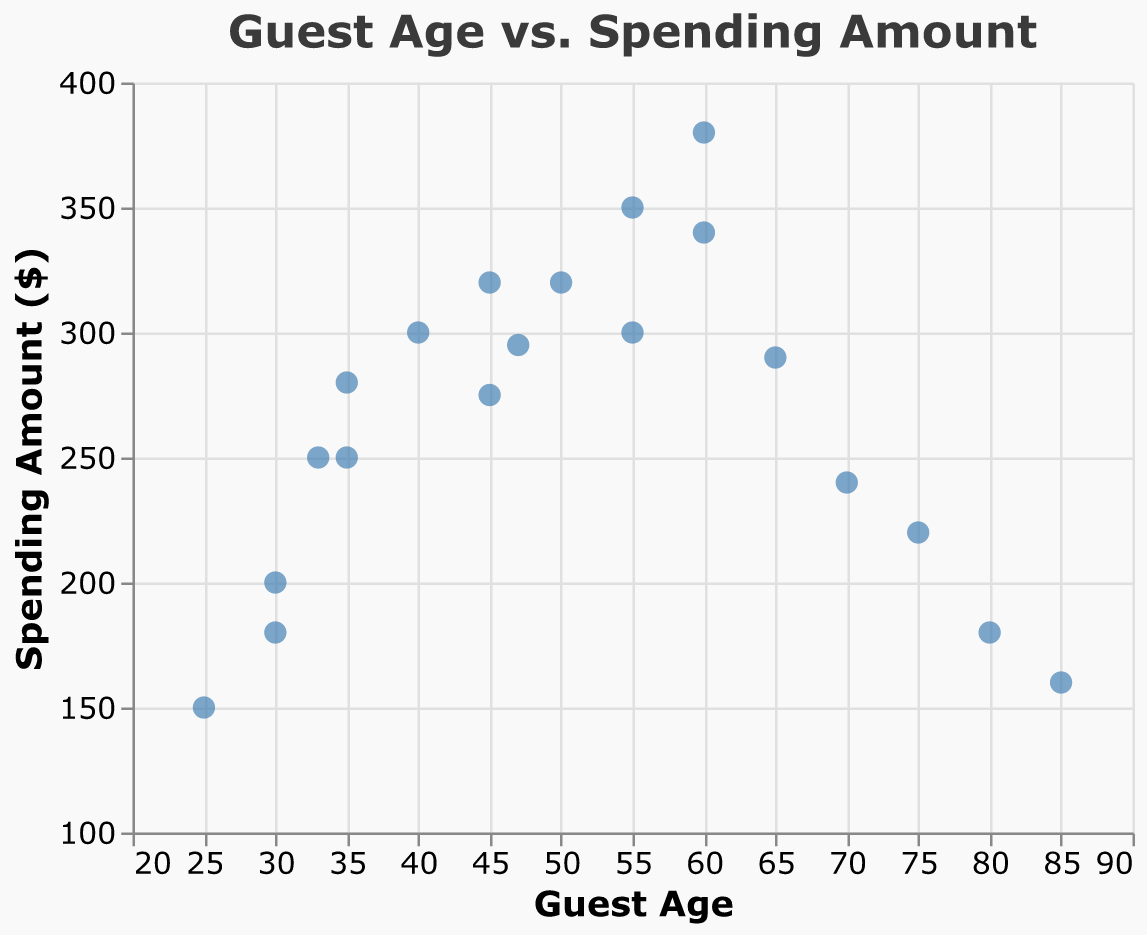What is the title of the scatter plot? The title is displayed prominently at the top of the scatter plot and uses a larger font size along with a different color for distinction.
Answer: Guest Age vs. Spending Amount How many data points are shown on the scatter plot? To find the number of data points, count each individual point plotted on the chart.
Answer: 20 What is the spending amount for the guest aged 25? Locate the point corresponding to a guest age of 25 on the x-axis, then look up to see the y-value associated with that point.
Answer: $150 What is the range of guest ages represented in this scatter plot? The range can be identified by the minimum and maximum values on the x-axis. The x-axis scale shows values from 20 to 90.
Answer: 25-85 How many guests aged 60 are there, and what are their spending amounts? Find the points where the x-axis value is 60 and note their corresponding y-axis values. There are two such points.
Answer: 2 guests, $380 and $340 Which guest age has the highest spending amount, and what is that amount? Examine the y-axis to find the highest point on the plot, then look at the corresponding x-axis value.
Answer: Age 60, $380 What is the average spending amount for guests aged 35? Identify all data points where the guest age is 35, sum their spending amounts, and divide by the number of these data points. ($250 + $280) / 2.
Answer: $265 Is there a trend or pattern visible between guest age and spending amount? Look at the scatter plot and see if the points form a discernable pattern, such as increasing or decreasing. Generally, spending increases with age up to around 60 years, then tends to decrease.
Answer: Yes, generally increasing then decreasing Which age groups have the most variability in spending? Identify age groups with wider spread (variance) in their spending amount by observing the vertical spread of points for each age. Ages 30, 35, and 60 display a range of spending amounts, indicating high variability.
Answer: Ages 30, 35, 60 Do any age groups have a spending amount that stands out significantly from others? Look for data points that deviate notably from the general trend or cluster of points. The guest aged 60 with the spending amount of $380 is a significant outlier due to its high value.
Answer: Yes, Age 60 with $380 